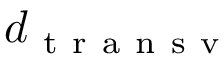<formula> <loc_0><loc_0><loc_500><loc_500>d _ { t r a n s v }</formula> 